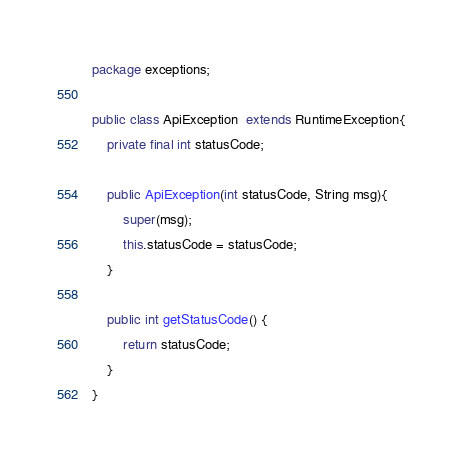<code> <loc_0><loc_0><loc_500><loc_500><_Java_>package exceptions;

public class ApiException  extends RuntimeException{
    private final int statusCode;

    public ApiException(int statusCode, String msg){
        super(msg);
        this.statusCode = statusCode;
    }

    public int getStatusCode() {
        return statusCode;
    }
}
</code> 